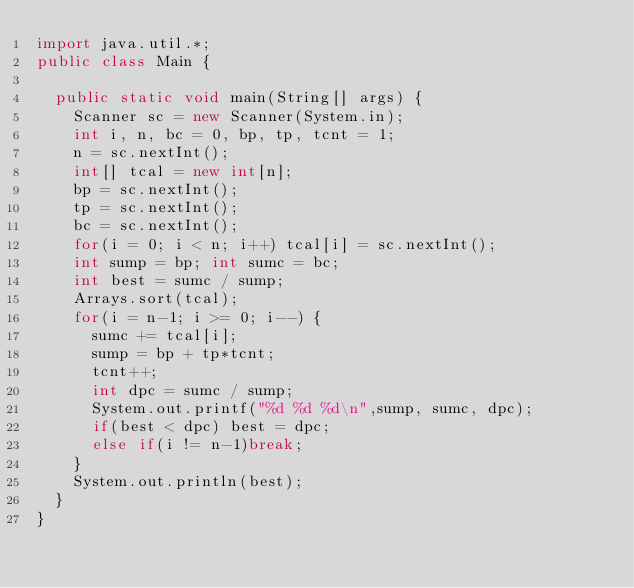Convert code to text. <code><loc_0><loc_0><loc_500><loc_500><_Java_>import java.util.*;
public class Main {

	public static void main(String[] args) {
		Scanner sc = new Scanner(System.in);
		int i, n, bc = 0, bp, tp, tcnt = 1;
		n = sc.nextInt();
		int[] tcal = new int[n];
		bp = sc.nextInt();
		tp = sc.nextInt();
		bc = sc.nextInt();
		for(i = 0; i < n; i++) tcal[i] = sc.nextInt();
		int sump = bp; int sumc = bc;
		int best = sumc / sump;
		Arrays.sort(tcal);
		for(i = n-1; i >= 0; i--) {
			sumc += tcal[i];
			sump = bp + tp*tcnt;
			tcnt++;
			int dpc = sumc / sump;
			System.out.printf("%d %d %d\n",sump, sumc, dpc);
			if(best < dpc) best = dpc;
			else if(i != n-1)break;
		}
		System.out.println(best);
	}
}</code> 